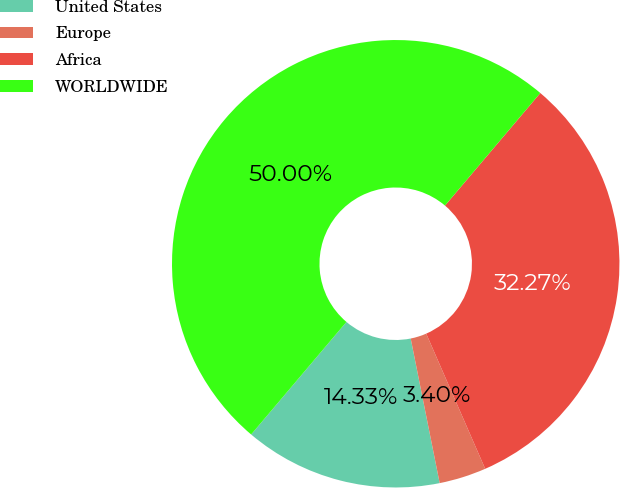<chart> <loc_0><loc_0><loc_500><loc_500><pie_chart><fcel>United States<fcel>Europe<fcel>Africa<fcel>WORLDWIDE<nl><fcel>14.33%<fcel>3.4%<fcel>32.27%<fcel>50.0%<nl></chart> 